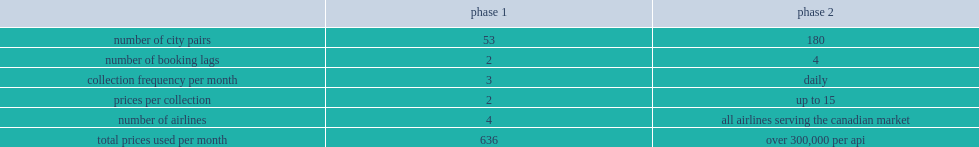What is the number of city pairs the second phase? 180.0. 